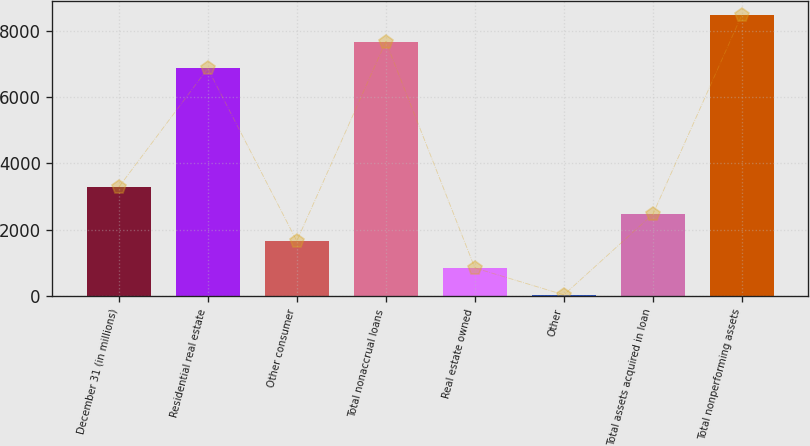<chart> <loc_0><loc_0><loc_500><loc_500><bar_chart><fcel>December 31 (in millions)<fcel>Residential real estate<fcel>Other consumer<fcel>Total nonaccrual loans<fcel>Real estate owned<fcel>Other<fcel>Total assets acquired in loan<fcel>Total nonperforming assets<nl><fcel>3285<fcel>6864<fcel>1663<fcel>7675<fcel>852<fcel>41<fcel>2474<fcel>8486<nl></chart> 